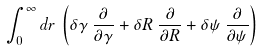<formula> <loc_0><loc_0><loc_500><loc_500>\int ^ { \infty } _ { 0 } d r \, \left ( { \delta } { \gamma } \, \frac { \partial } { { \partial } { \gamma } } + { \delta } R \, \frac { \partial } { { \partial } R } + { \delta } { \psi } \, \frac { \partial } { { \partial } { \psi } } \right )</formula> 